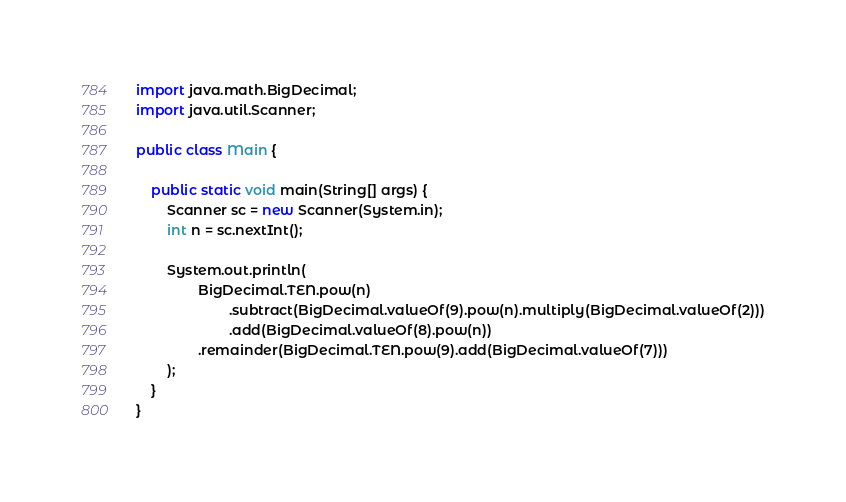Convert code to text. <code><loc_0><loc_0><loc_500><loc_500><_Java_>import java.math.BigDecimal;
import java.util.Scanner;

public class Main {

    public static void main(String[] args) {
        Scanner sc = new Scanner(System.in);
        int n = sc.nextInt();

        System.out.println(
                BigDecimal.TEN.pow(n)
                        .subtract(BigDecimal.valueOf(9).pow(n).multiply(BigDecimal.valueOf(2)))
                        .add(BigDecimal.valueOf(8).pow(n))
                .remainder(BigDecimal.TEN.pow(9).add(BigDecimal.valueOf(7)))
        );
    }
}
</code> 